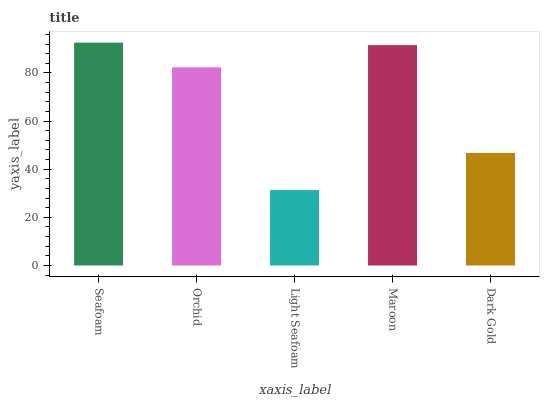Is Light Seafoam the minimum?
Answer yes or no. Yes. Is Seafoam the maximum?
Answer yes or no. Yes. Is Orchid the minimum?
Answer yes or no. No. Is Orchid the maximum?
Answer yes or no. No. Is Seafoam greater than Orchid?
Answer yes or no. Yes. Is Orchid less than Seafoam?
Answer yes or no. Yes. Is Orchid greater than Seafoam?
Answer yes or no. No. Is Seafoam less than Orchid?
Answer yes or no. No. Is Orchid the high median?
Answer yes or no. Yes. Is Orchid the low median?
Answer yes or no. Yes. Is Light Seafoam the high median?
Answer yes or no. No. Is Seafoam the low median?
Answer yes or no. No. 